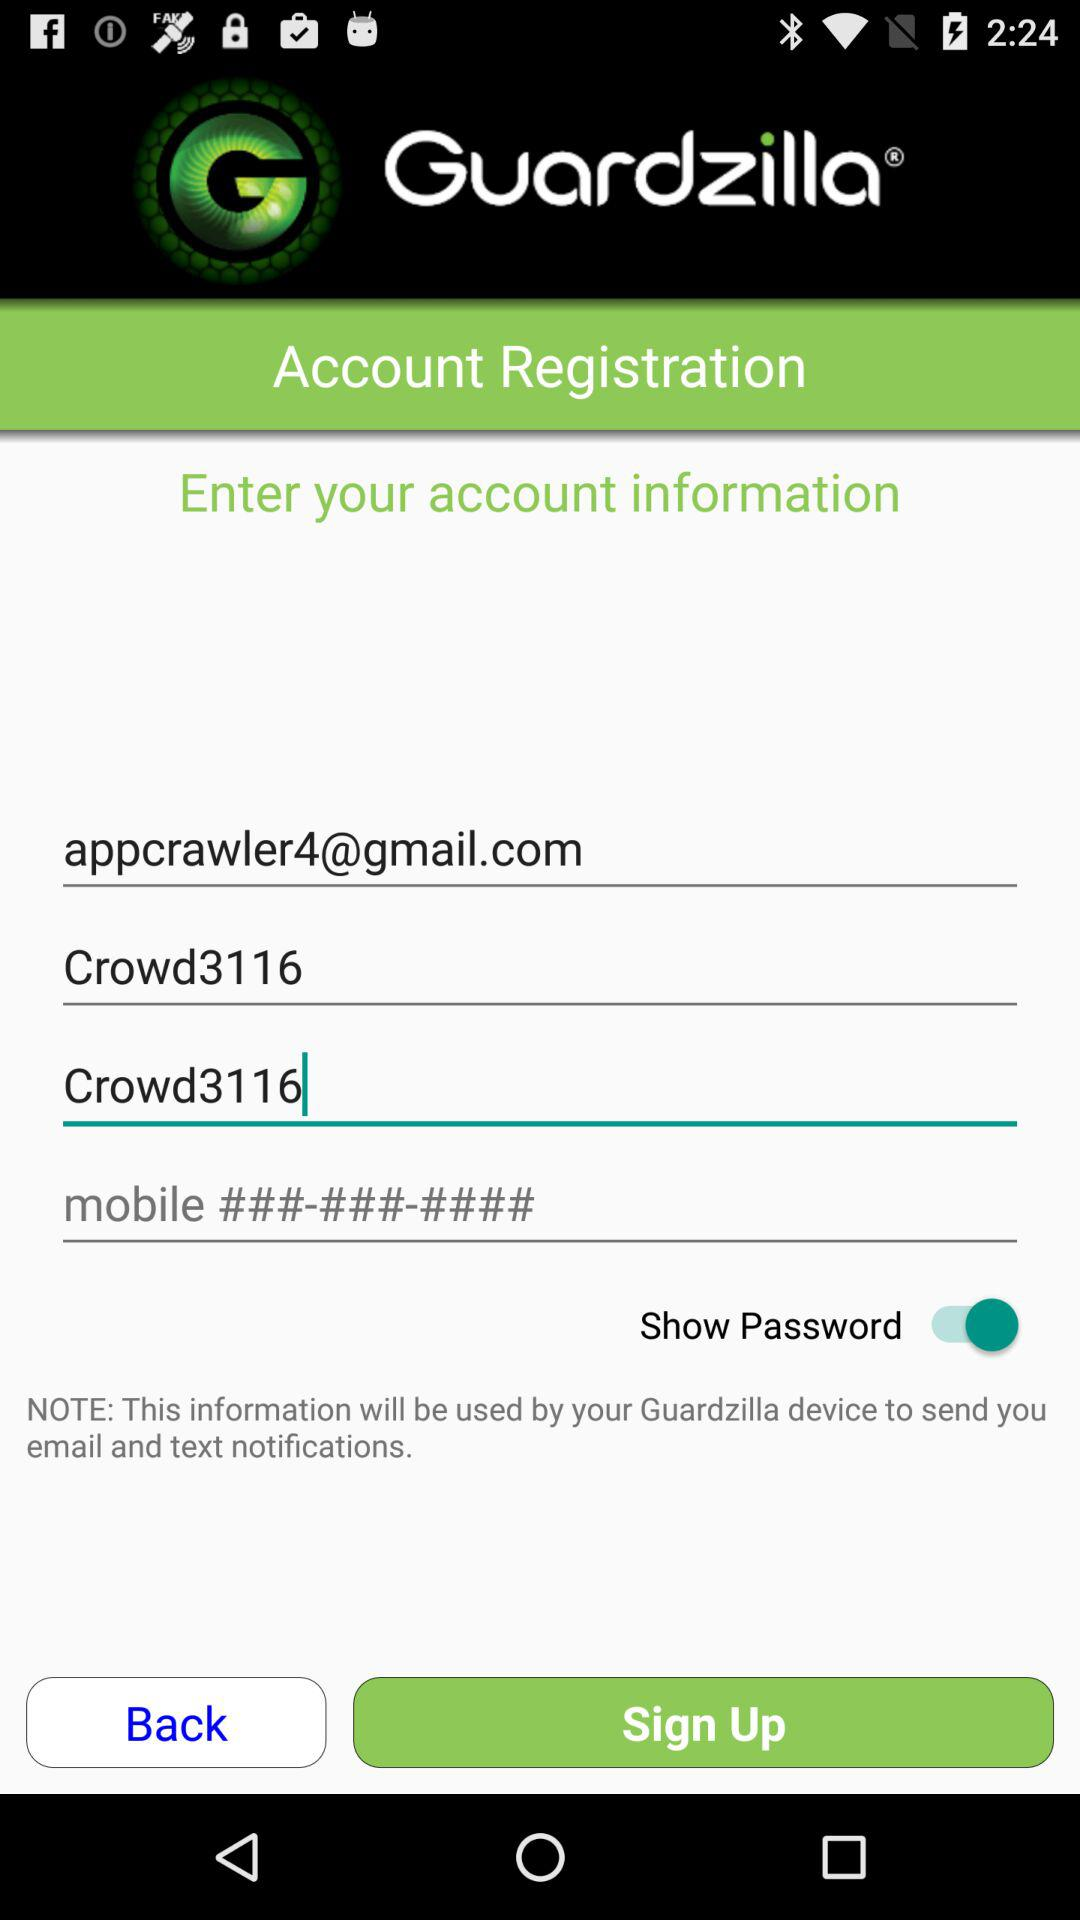What is the status of the show password? The status is on. 